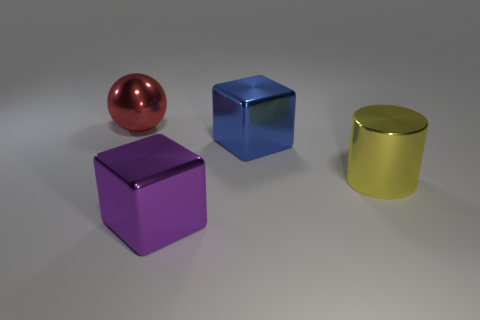Add 3 big yellow metal things. How many objects exist? 7 Subtract all balls. How many objects are left? 3 Subtract all yellow things. Subtract all green objects. How many objects are left? 3 Add 2 metallic cubes. How many metallic cubes are left? 4 Add 2 cylinders. How many cylinders exist? 3 Subtract 0 yellow blocks. How many objects are left? 4 